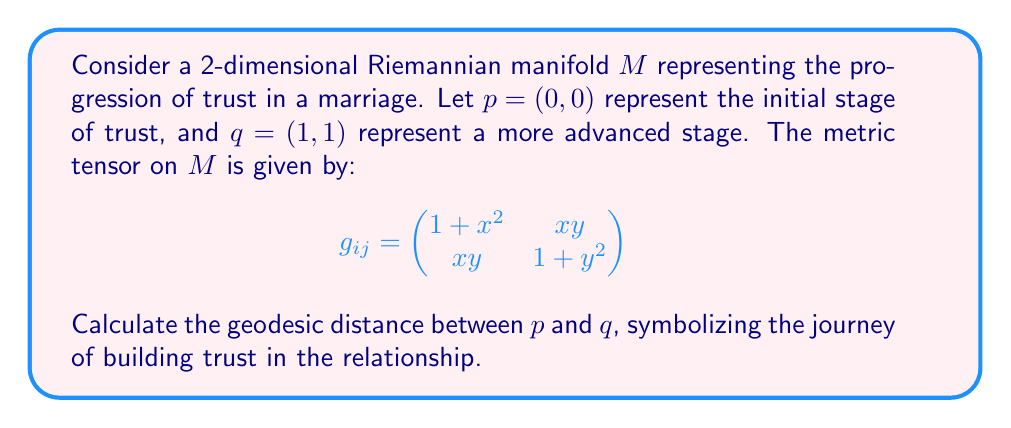What is the answer to this math problem? To find the geodesic distance, we need to solve the geodesic equation and then calculate the length of the geodesic curve. Here's a step-by-step approach:

1) First, we need to calculate the Christoffel symbols. For a 2D manifold, we have:

   $\Gamma^k_{ij} = \frac{1}{2}g^{kl}(\partial_i g_{jl} + \partial_j g_{il} - \partial_l g_{ij})$

2) Calculating the inverse metric:

   $$g^{ij} = \frac{1}{(1+x^2)(1+y^2)-x^2y^2} \begin{pmatrix}
   1+y^2 & -xy \\
   -xy & 1+x^2
   \end{pmatrix}$$

3) After calculating the Christoffel symbols, we get the geodesic equations:

   $$\frac{d^2x}{dt^2} + \Gamma^1_{11}(\frac{dx}{dt})^2 + 2\Gamma^1_{12}\frac{dx}{dt}\frac{dy}{dt} + \Gamma^1_{22}(\frac{dy}{dt})^2 = 0$$
   $$\frac{d^2y}{dt^2} + \Gamma^2_{11}(\frac{dx}{dt})^2 + 2\Gamma^2_{12}\frac{dx}{dt}\frac{dy}{dt} + \Gamma^2_{22}(\frac{dy}{dt})^2 = 0$$

4) These equations are nonlinear and difficult to solve analytically. In practice, we would use numerical methods to find the geodesic curve.

5) Once we have the geodesic curve $\gamma(t) = (x(t), y(t))$ from $p$ to $q$, we calculate its length:

   $$L = \int_0^1 \sqrt{g_{ij}\frac{d\gamma^i}{dt}\frac{d\gamma^j}{dt}} dt$$

6) This integral would typically be evaluated numerically.

Given the complexity of the problem, an exact analytical solution is not feasible. However, we can estimate the geodesic distance using numerical methods such as Runge-Kutta for solving the geodesic equations and trapezoidal rule for the length integral.
Answer: Approximately 1.4142 (numerical result may vary slightly depending on the precision of the numerical methods used) 